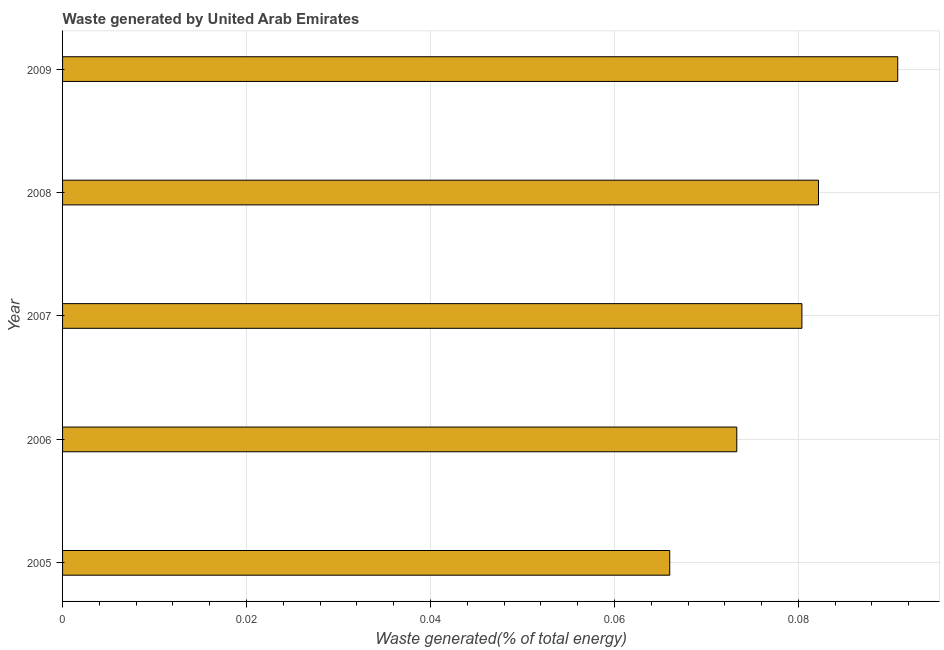What is the title of the graph?
Make the answer very short. Waste generated by United Arab Emirates. What is the label or title of the X-axis?
Ensure brevity in your answer.  Waste generated(% of total energy). What is the label or title of the Y-axis?
Ensure brevity in your answer.  Year. What is the amount of waste generated in 2006?
Keep it short and to the point. 0.07. Across all years, what is the maximum amount of waste generated?
Your answer should be compact. 0.09. Across all years, what is the minimum amount of waste generated?
Your answer should be compact. 0.07. In which year was the amount of waste generated maximum?
Provide a short and direct response. 2009. What is the sum of the amount of waste generated?
Give a very brief answer. 0.39. What is the difference between the amount of waste generated in 2007 and 2008?
Offer a very short reply. -0. What is the average amount of waste generated per year?
Ensure brevity in your answer.  0.08. What is the median amount of waste generated?
Provide a succinct answer. 0.08. What is the ratio of the amount of waste generated in 2005 to that in 2007?
Offer a terse response. 0.82. Is the amount of waste generated in 2006 less than that in 2007?
Ensure brevity in your answer.  Yes. Is the difference between the amount of waste generated in 2005 and 2008 greater than the difference between any two years?
Provide a short and direct response. No. What is the difference between the highest and the second highest amount of waste generated?
Make the answer very short. 0.01. Is the sum of the amount of waste generated in 2008 and 2009 greater than the maximum amount of waste generated across all years?
Offer a very short reply. Yes. In how many years, is the amount of waste generated greater than the average amount of waste generated taken over all years?
Your answer should be compact. 3. Are all the bars in the graph horizontal?
Your response must be concise. Yes. What is the Waste generated(% of total energy) in 2005?
Your response must be concise. 0.07. What is the Waste generated(% of total energy) in 2006?
Offer a very short reply. 0.07. What is the Waste generated(% of total energy) of 2007?
Provide a short and direct response. 0.08. What is the Waste generated(% of total energy) of 2008?
Give a very brief answer. 0.08. What is the Waste generated(% of total energy) in 2009?
Offer a very short reply. 0.09. What is the difference between the Waste generated(% of total energy) in 2005 and 2006?
Ensure brevity in your answer.  -0.01. What is the difference between the Waste generated(% of total energy) in 2005 and 2007?
Provide a short and direct response. -0.01. What is the difference between the Waste generated(% of total energy) in 2005 and 2008?
Your response must be concise. -0.02. What is the difference between the Waste generated(% of total energy) in 2005 and 2009?
Offer a very short reply. -0.02. What is the difference between the Waste generated(% of total energy) in 2006 and 2007?
Your response must be concise. -0.01. What is the difference between the Waste generated(% of total energy) in 2006 and 2008?
Provide a short and direct response. -0.01. What is the difference between the Waste generated(% of total energy) in 2006 and 2009?
Make the answer very short. -0.02. What is the difference between the Waste generated(% of total energy) in 2007 and 2008?
Your answer should be compact. -0. What is the difference between the Waste generated(% of total energy) in 2007 and 2009?
Your answer should be very brief. -0.01. What is the difference between the Waste generated(% of total energy) in 2008 and 2009?
Make the answer very short. -0.01. What is the ratio of the Waste generated(% of total energy) in 2005 to that in 2006?
Make the answer very short. 0.9. What is the ratio of the Waste generated(% of total energy) in 2005 to that in 2007?
Give a very brief answer. 0.82. What is the ratio of the Waste generated(% of total energy) in 2005 to that in 2008?
Your response must be concise. 0.8. What is the ratio of the Waste generated(% of total energy) in 2005 to that in 2009?
Your response must be concise. 0.73. What is the ratio of the Waste generated(% of total energy) in 2006 to that in 2007?
Provide a short and direct response. 0.91. What is the ratio of the Waste generated(% of total energy) in 2006 to that in 2008?
Provide a succinct answer. 0.89. What is the ratio of the Waste generated(% of total energy) in 2006 to that in 2009?
Make the answer very short. 0.81. What is the ratio of the Waste generated(% of total energy) in 2007 to that in 2009?
Your response must be concise. 0.89. What is the ratio of the Waste generated(% of total energy) in 2008 to that in 2009?
Your answer should be compact. 0.91. 